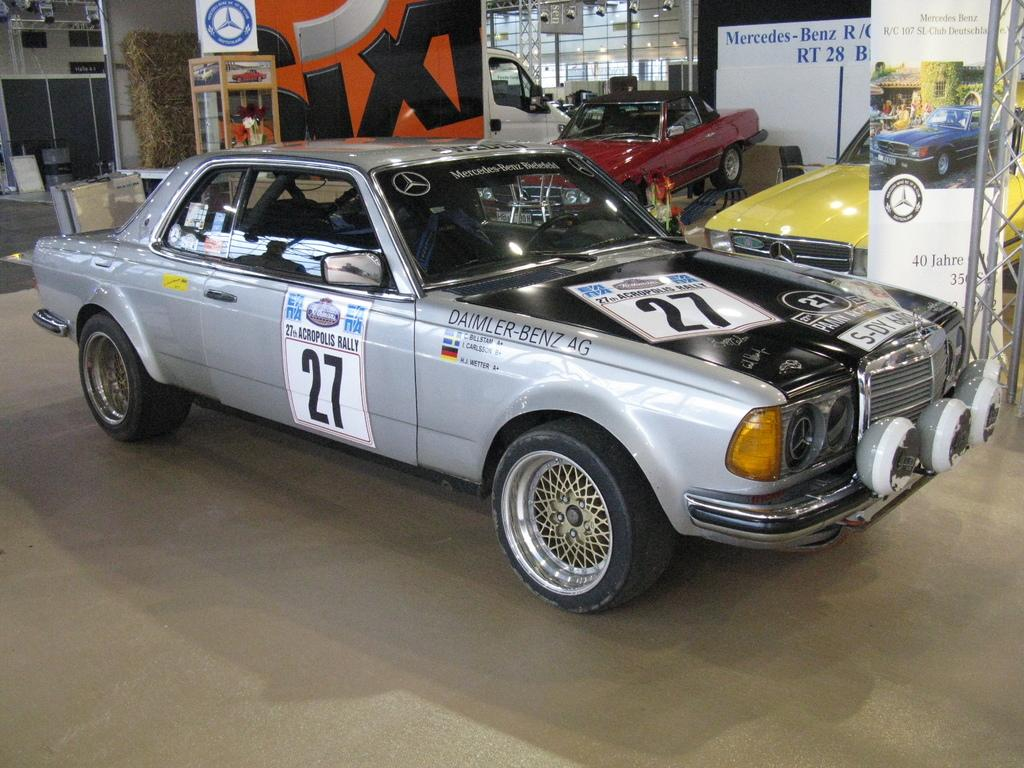What type of vehicles are present in the image? There are cars in the image. What is the status of the cars in the image? The cars are parked. Where is the image likely to have been taken? The location is a car showroom. What type of pets can be seen interacting with the cars in the image? There are no pets present in the image; it features parked cars in a showroom. 